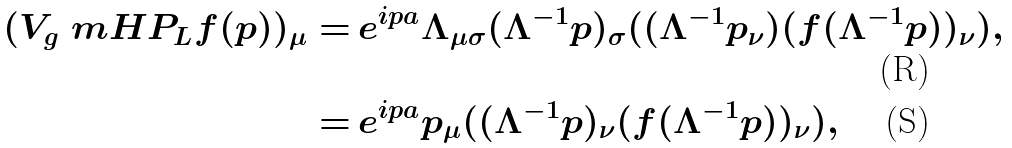<formula> <loc_0><loc_0><loc_500><loc_500>( V _ { g } \ m H P _ { \L L } f ( p ) ) _ { \mu } = & \, e ^ { i p a } \Lambda _ { \mu \sigma } ( \Lambda ^ { - 1 } p ) _ { \sigma } ( ( \Lambda ^ { - 1 } p _ { \nu } ) ( f ( \Lambda ^ { - 1 } p ) ) _ { \nu } ) , \\ = & \, e ^ { i p a } p _ { \mu } ( ( \Lambda ^ { - 1 } p ) _ { \nu } ( f ( \Lambda ^ { - 1 } p ) ) _ { \nu } ) ,</formula> 